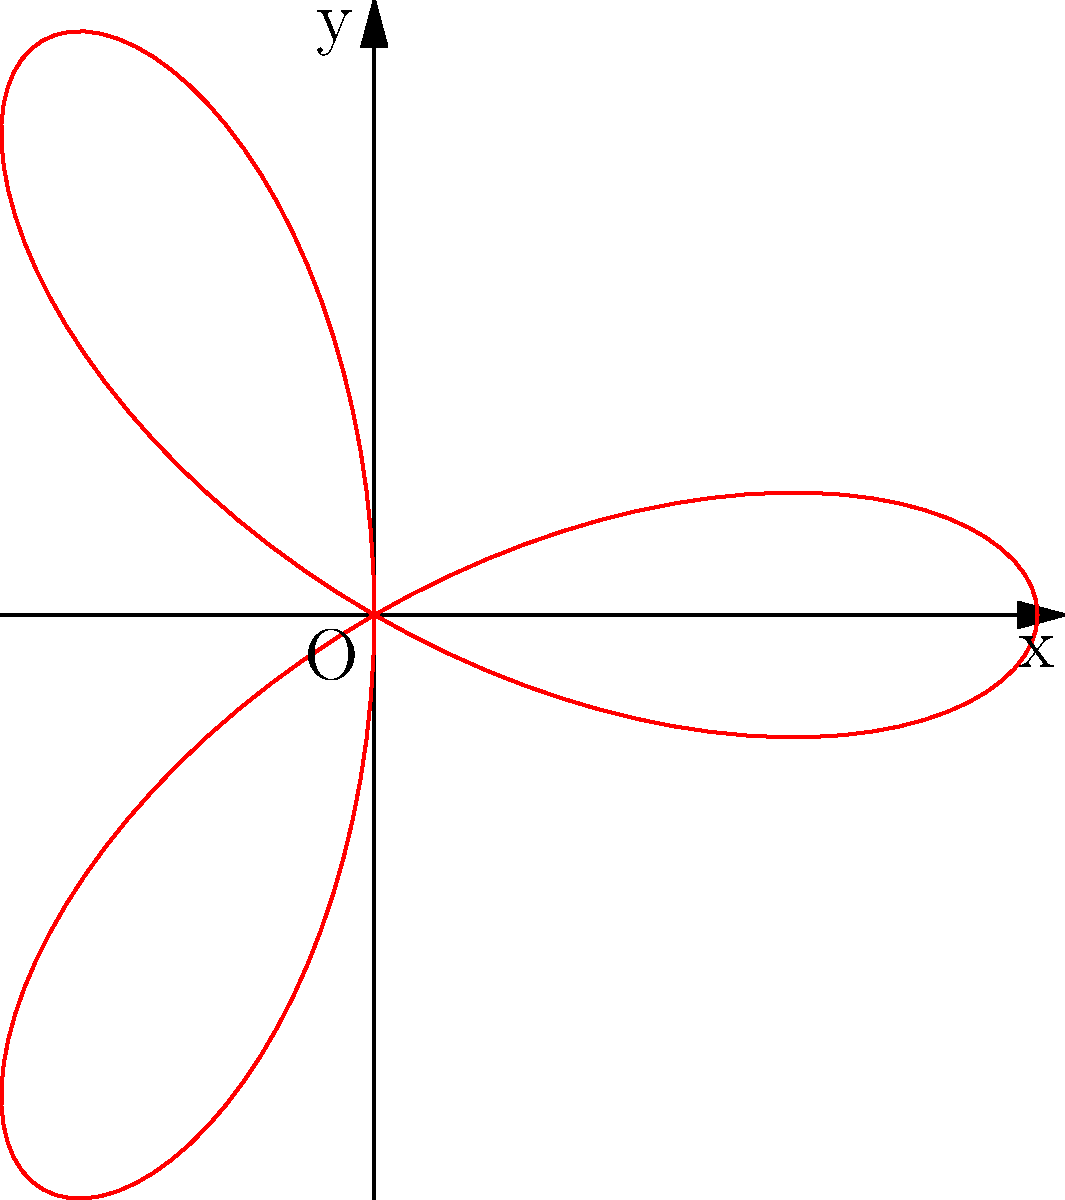The rhythm pattern of a classic Bollywood song sung by K.J. Yesudas can be represented by the rose curve $r = 2\cos(3\theta)$. Calculate the area enclosed by this curve. To find the area enclosed by the rose curve, we'll follow these steps:

1) The general formula for the area enclosed by a polar curve is:
   $$A = \frac{1}{2} \int_{0}^{2\pi} r^2 d\theta$$

2) In this case, $r = 2\cos(3\theta)$. We need to square this:
   $$r^2 = 4\cos^2(3\theta)$$

3) Substituting into the area formula:
   $$A = \frac{1}{2} \int_{0}^{2\pi} 4\cos^2(3\theta) d\theta$$

4) Using the trigonometric identity $\cos^2 x = \frac{1 + \cos(2x)}{2}$:
   $$A = 2 \int_{0}^{2\pi} \frac{1 + \cos(6\theta)}{2} d\theta$$
   $$A = \int_{0}^{2\pi} (1 + \cos(6\theta)) d\theta$$

5) Integrating:
   $$A = [\theta + \frac{1}{6}\sin(6\theta)]_{0}^{2\pi}$$

6) Evaluating at the limits:
   $$A = (2\pi + 0) - (0 + 0) = 2\pi$$

Therefore, the area enclosed by the rose curve is $2\pi$ square units.
Answer: $2\pi$ square units 